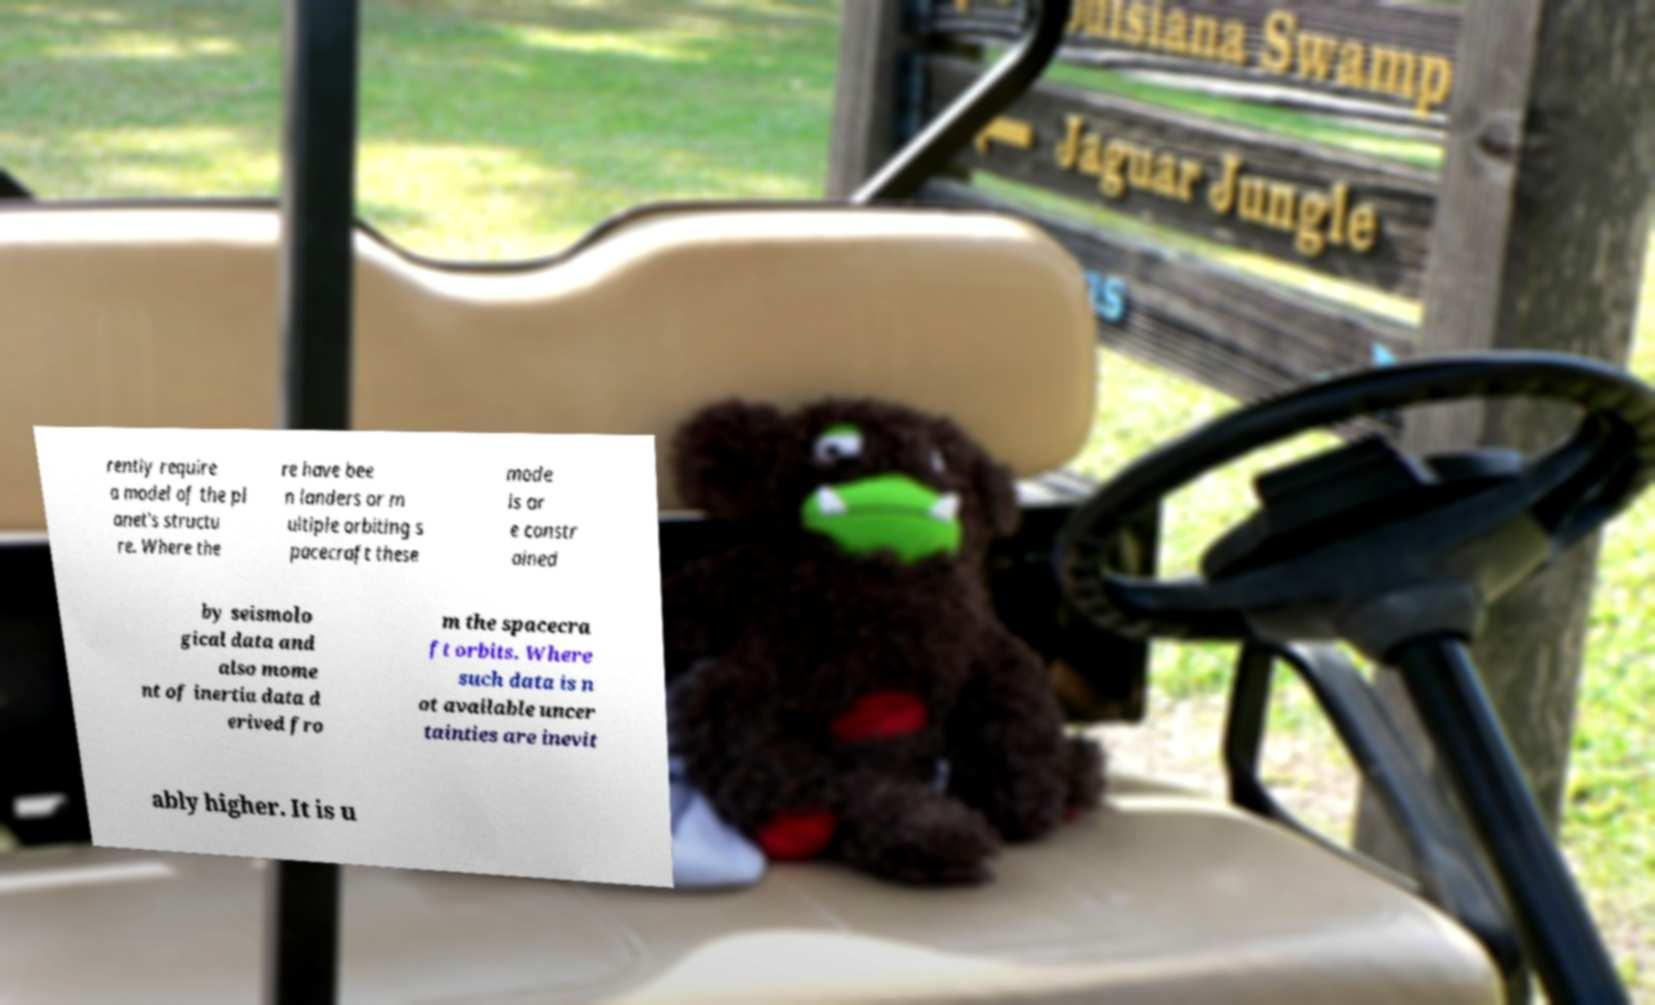Could you extract and type out the text from this image? rently require a model of the pl anet's structu re. Where the re have bee n landers or m ultiple orbiting s pacecraft these mode ls ar e constr ained by seismolo gical data and also mome nt of inertia data d erived fro m the spacecra ft orbits. Where such data is n ot available uncer tainties are inevit ably higher. It is u 